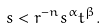<formula> <loc_0><loc_0><loc_500><loc_500>s < r ^ { - n } s ^ { \alpha } t ^ { \beta } .</formula> 